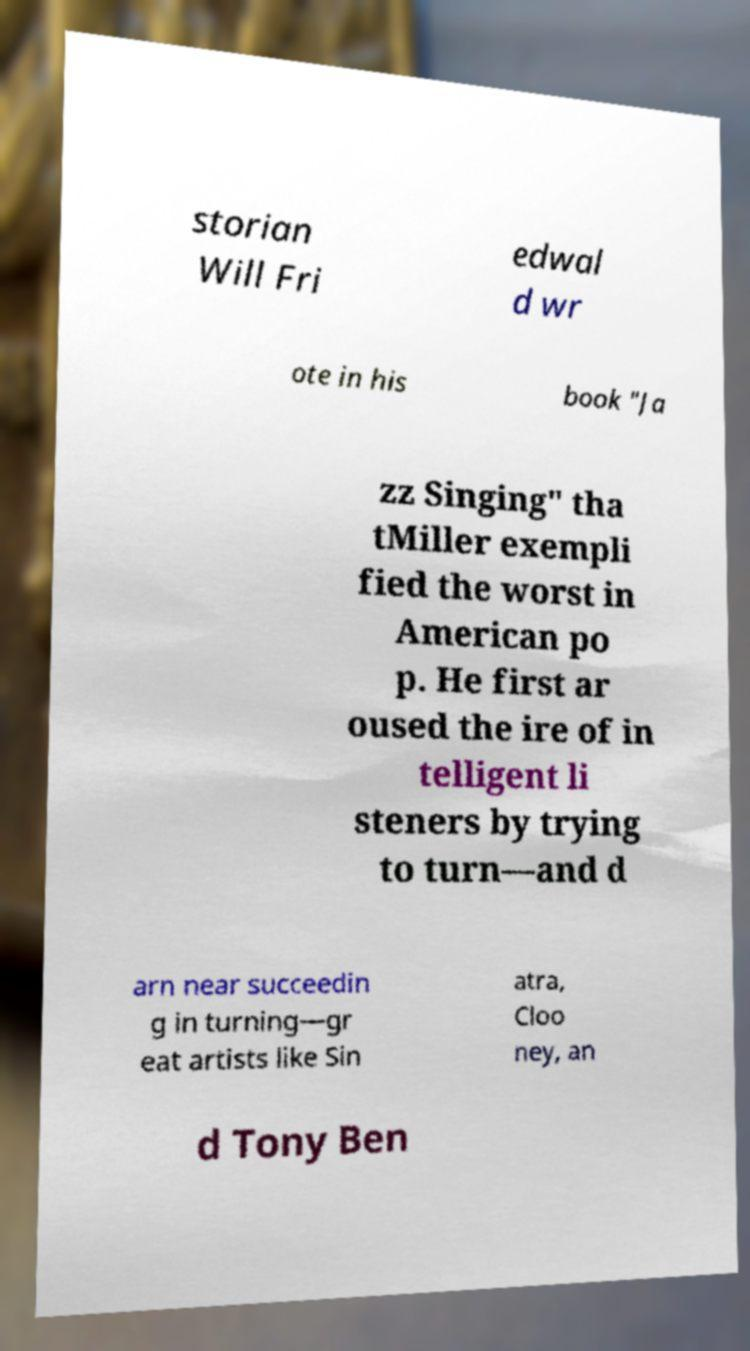Please identify and transcribe the text found in this image. storian Will Fri edwal d wr ote in his book "Ja zz Singing" tha tMiller exempli fied the worst in American po p. He first ar oused the ire of in telligent li steners by trying to turn—and d arn near succeedin g in turning—gr eat artists like Sin atra, Cloo ney, an d Tony Ben 